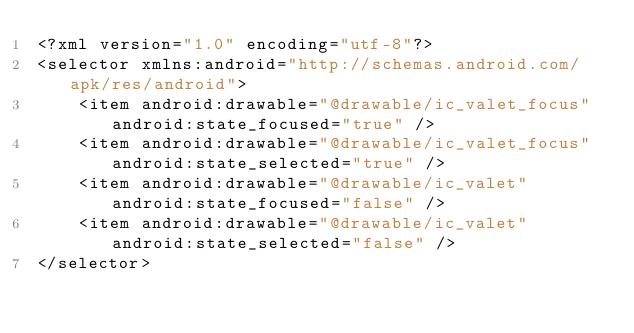Convert code to text. <code><loc_0><loc_0><loc_500><loc_500><_XML_><?xml version="1.0" encoding="utf-8"?>
<selector xmlns:android="http://schemas.android.com/apk/res/android">
    <item android:drawable="@drawable/ic_valet_focus" android:state_focused="true" />
    <item android:drawable="@drawable/ic_valet_focus" android:state_selected="true" />
    <item android:drawable="@drawable/ic_valet" android:state_focused="false" />
    <item android:drawable="@drawable/ic_valet" android:state_selected="false" />
</selector>

</code> 